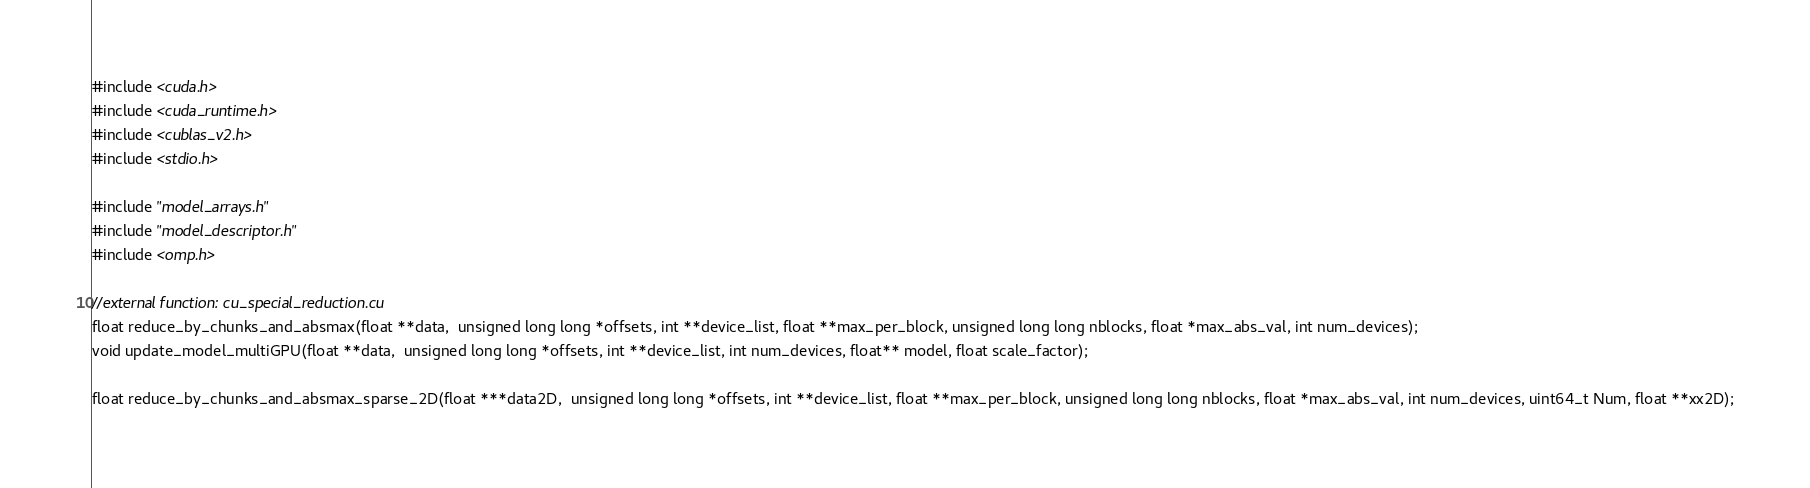<code> <loc_0><loc_0><loc_500><loc_500><_Cuda_>

#include <cuda.h>
#include <cuda_runtime.h>
#include <cublas_v2.h>
#include <stdio.h>

#include "model_arrays.h"
#include "model_descriptor.h"
#include <omp.h>

//external function: cu_special_reduction.cu
float reduce_by_chunks_and_absmax(float **data,  unsigned long long *offsets, int **device_list, float **max_per_block, unsigned long long nblocks, float *max_abs_val, int num_devices);
void update_model_multiGPU(float **data,  unsigned long long *offsets, int **device_list, int num_devices, float** model, float scale_factor);

float reduce_by_chunks_and_absmax_sparse_2D(float ***data2D,  unsigned long long *offsets, int **device_list, float **max_per_block, unsigned long long nblocks, float *max_abs_val, int num_devices, uint64_t Num, float **xx2D);</code> 